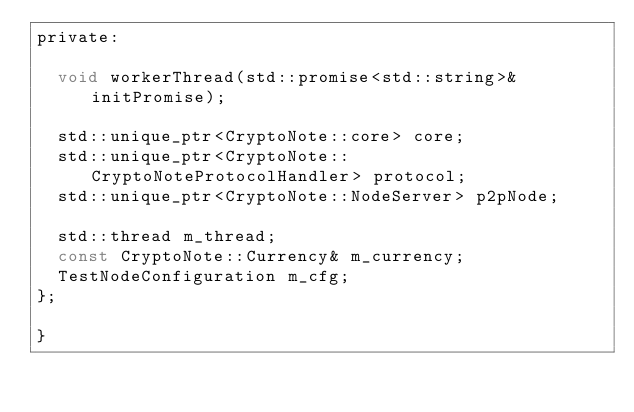<code> <loc_0><loc_0><loc_500><loc_500><_C_>private:

  void workerThread(std::promise<std::string>& initPromise);

  std::unique_ptr<CryptoNote::core> core;
  std::unique_ptr<CryptoNote::CryptoNoteProtocolHandler> protocol;
  std::unique_ptr<CryptoNote::NodeServer> p2pNode;

  std::thread m_thread;
  const CryptoNote::Currency& m_currency;
  TestNodeConfiguration m_cfg;
};

}
</code> 